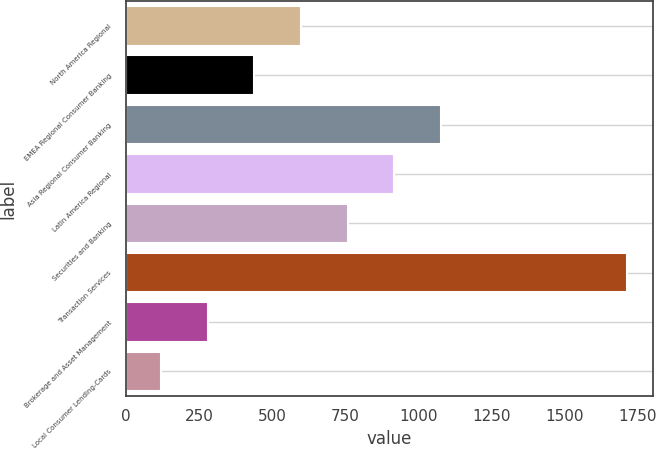Convert chart to OTSL. <chart><loc_0><loc_0><loc_500><loc_500><bar_chart><fcel>North America Regional<fcel>EMEA Regional Consumer Banking<fcel>Asia Regional Consumer Banking<fcel>Latin America Regional<fcel>Securities and Banking<fcel>Transaction Services<fcel>Brokerage and Asset Management<fcel>Local Consumer Lending-Cards<nl><fcel>599.5<fcel>440<fcel>1078<fcel>918.5<fcel>759<fcel>1716<fcel>280.5<fcel>121<nl></chart> 